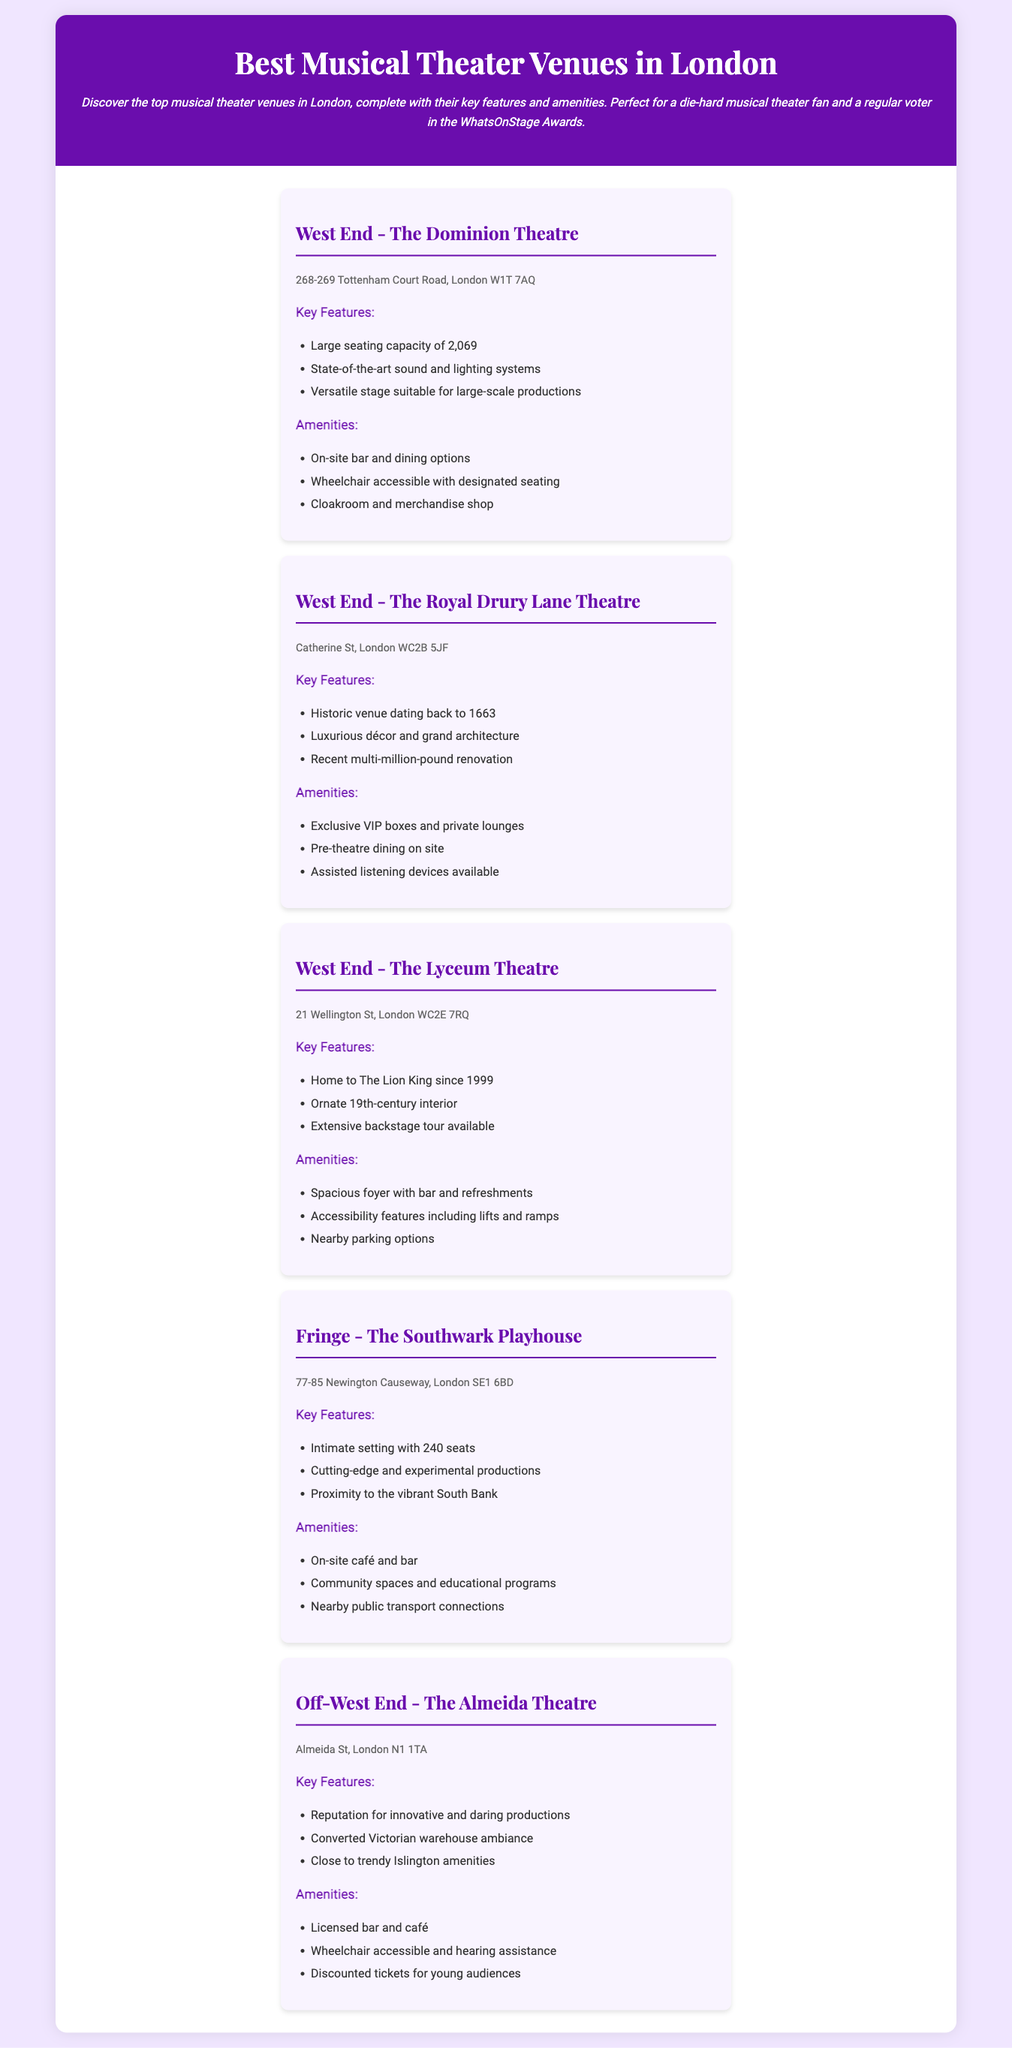what is the seating capacity of the Dominion Theatre? The seating capacity of the Dominion Theatre is specifically stated in the document as 2,069.
Answer: 2,069 what is the address of The Royal Drury Lane Theatre? The address is clearly mentioned in the document as Catherine St, London WC2B 5JF.
Answer: Catherine St, London WC2B 5JF which venue is known for hosting The Lion King? The document indicates that The Lyceum Theatre has been home to The Lion King since 1999.
Answer: The Lyceum Theatre what year was The Royal Drury Lane Theatre established? The document provides the historical detail that the venue dates back to 1663.
Answer: 1663 how many seats does The Southwark Playhouse have? The document states that The Southwark Playhouse has an intimate setting with 240 seats.
Answer: 240 which theatre features luxurious décor and grand architecture? The Royal Drury Lane Theatre is highlighted in the document for its luxurious décor and grand architecture.
Answer: The Royal Drury Lane Theatre how many venues are located in the West End according to the document? The document lists three venues specifically in the West End: The Dominion Theatre, The Royal Drury Lane Theatre, and The Lyceum Theatre.
Answer: Three what type of productions is The Almeida Theatre known for? The document describes The Almeida Theatre as having a reputation for innovative and daring productions.
Answer: Innovative and daring what is a unique aspect of The Southwark Playhouse? The Southwark Playhouse is noted for its cutting-edge and experimental productions in the document.
Answer: Experimental productions 